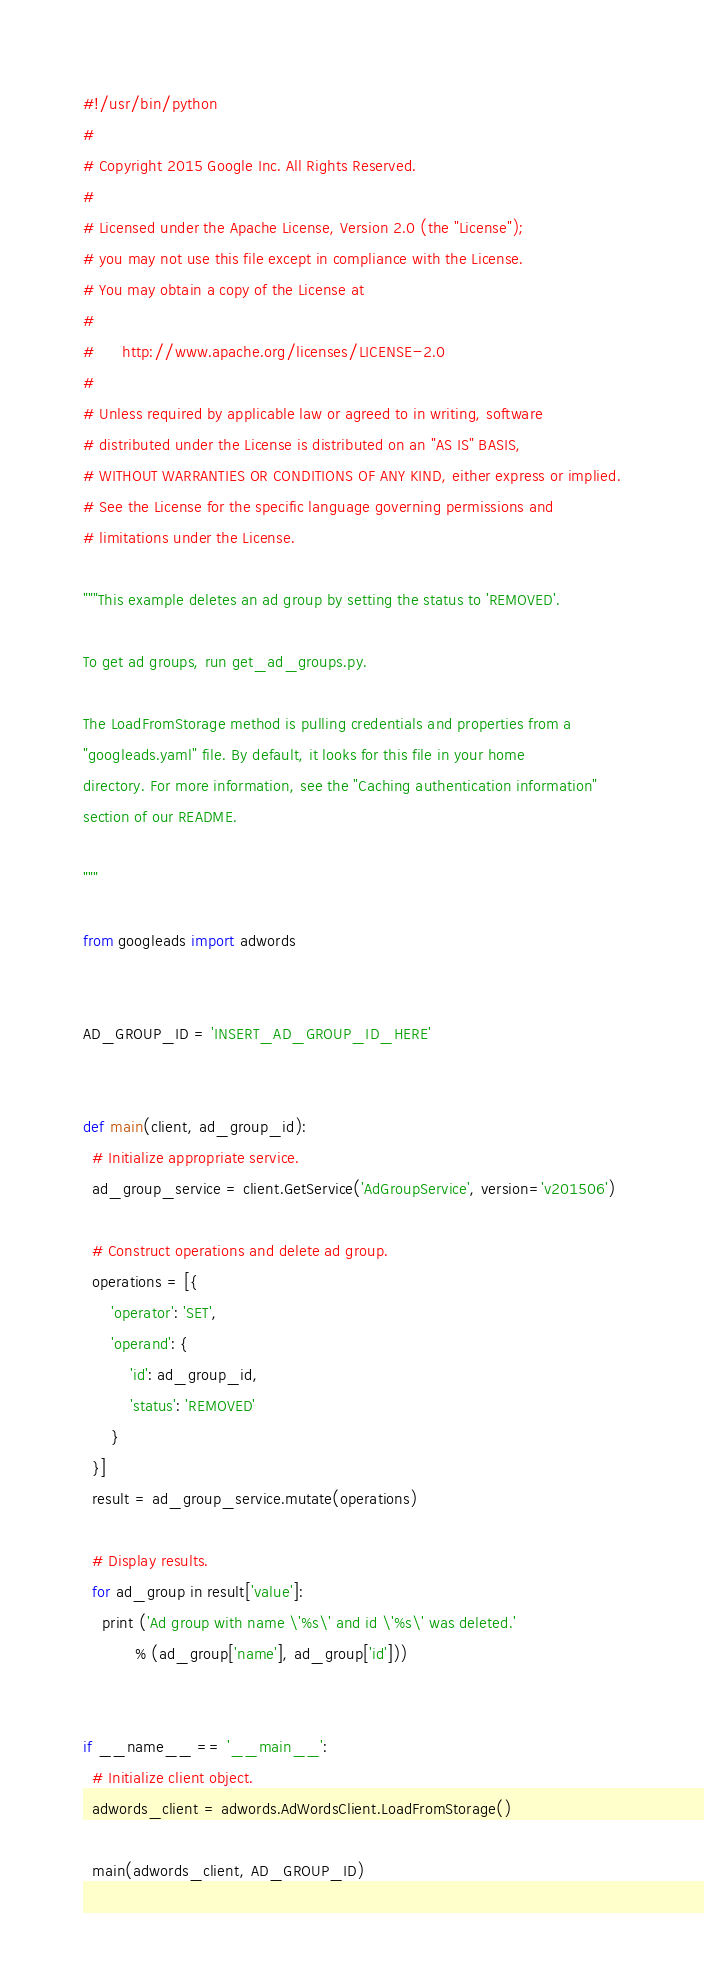<code> <loc_0><loc_0><loc_500><loc_500><_Python_>#!/usr/bin/python
#
# Copyright 2015 Google Inc. All Rights Reserved.
#
# Licensed under the Apache License, Version 2.0 (the "License");
# you may not use this file except in compliance with the License.
# You may obtain a copy of the License at
#
#      http://www.apache.org/licenses/LICENSE-2.0
#
# Unless required by applicable law or agreed to in writing, software
# distributed under the License is distributed on an "AS IS" BASIS,
# WITHOUT WARRANTIES OR CONDITIONS OF ANY KIND, either express or implied.
# See the License for the specific language governing permissions and
# limitations under the License.

"""This example deletes an ad group by setting the status to 'REMOVED'.

To get ad groups, run get_ad_groups.py.

The LoadFromStorage method is pulling credentials and properties from a
"googleads.yaml" file. By default, it looks for this file in your home
directory. For more information, see the "Caching authentication information"
section of our README.

"""

from googleads import adwords


AD_GROUP_ID = 'INSERT_AD_GROUP_ID_HERE'


def main(client, ad_group_id):
  # Initialize appropriate service.
  ad_group_service = client.GetService('AdGroupService', version='v201506')

  # Construct operations and delete ad group.
  operations = [{
      'operator': 'SET',
      'operand': {
          'id': ad_group_id,
          'status': 'REMOVED'
      }
  }]
  result = ad_group_service.mutate(operations)

  # Display results.
  for ad_group in result['value']:
    print ('Ad group with name \'%s\' and id \'%s\' was deleted.'
           % (ad_group['name'], ad_group['id']))


if __name__ == '__main__':
  # Initialize client object.
  adwords_client = adwords.AdWordsClient.LoadFromStorage()

  main(adwords_client, AD_GROUP_ID)
</code> 